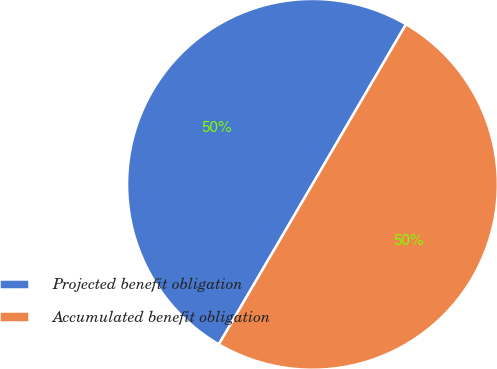Convert chart to OTSL. <chart><loc_0><loc_0><loc_500><loc_500><pie_chart><fcel>Projected benefit obligation<fcel>Accumulated benefit obligation<nl><fcel>49.99%<fcel>50.01%<nl></chart> 